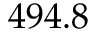Convert formula to latex. <formula><loc_0><loc_0><loc_500><loc_500>4 9 4 . 8</formula> 